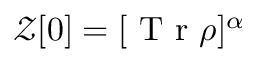<formula> <loc_0><loc_0><loc_500><loc_500>\mathcal { Z } [ 0 ] = [ T r \rho ] ^ { \alpha }</formula> 